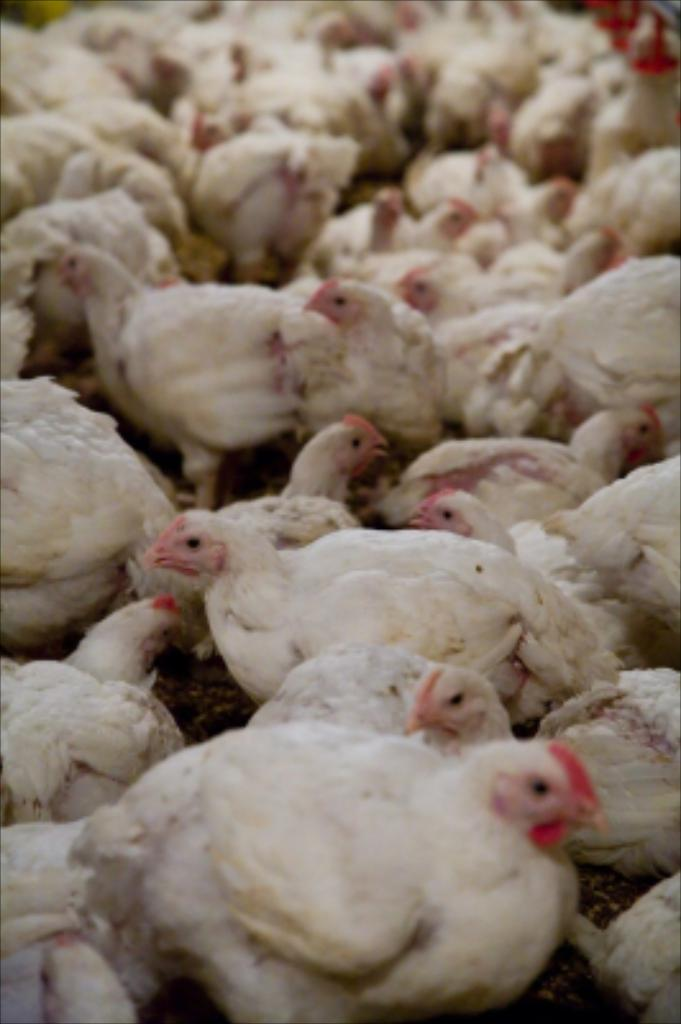What type of animals are present in the image? There are white color chickens in the image. Can you describe the quality of the background in the image? The image is blurry in the background. How many jellyfish can be seen swimming in the image? There are no jellyfish present in the image; it features white color chickens. What type of fiction is being depicted in the image? The image does not depict any fiction; it shows white color chickens. 